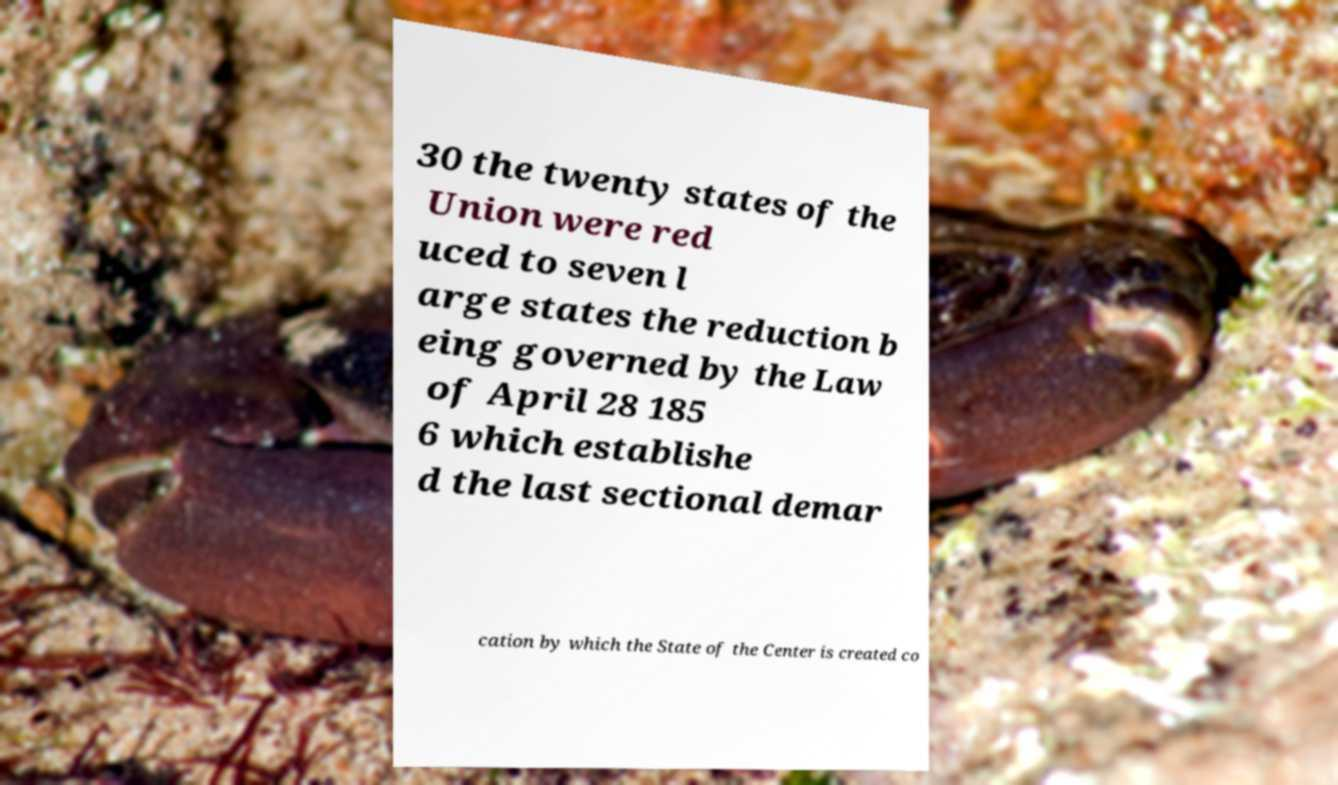There's text embedded in this image that I need extracted. Can you transcribe it verbatim? 30 the twenty states of the Union were red uced to seven l arge states the reduction b eing governed by the Law of April 28 185 6 which establishe d the last sectional demar cation by which the State of the Center is created co 